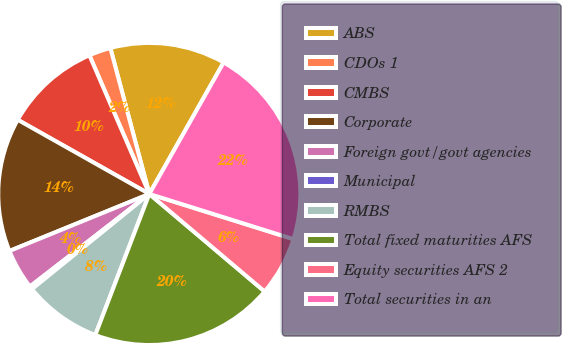Convert chart to OTSL. <chart><loc_0><loc_0><loc_500><loc_500><pie_chart><fcel>ABS<fcel>CDOs 1<fcel>CMBS<fcel>Corporate<fcel>Foreign govt/govt agencies<fcel>Municipal<fcel>RMBS<fcel>Total fixed maturities AFS<fcel>Equity securities AFS 2<fcel>Total securities in an<nl><fcel>12.34%<fcel>2.34%<fcel>10.34%<fcel>14.33%<fcel>4.34%<fcel>0.34%<fcel>8.34%<fcel>19.65%<fcel>6.34%<fcel>21.65%<nl></chart> 